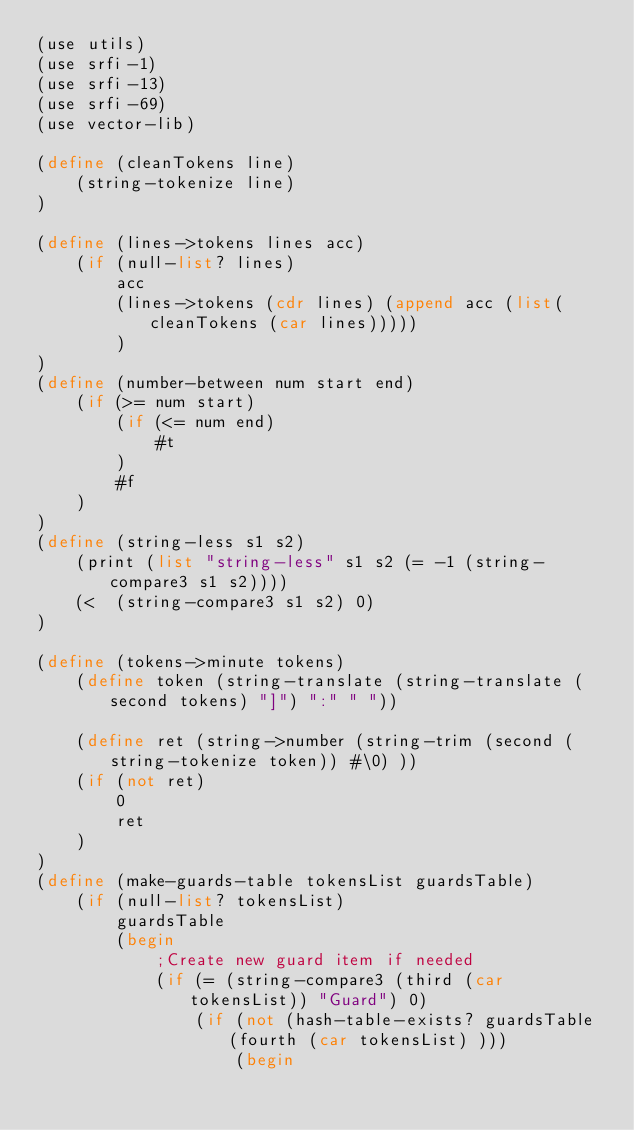<code> <loc_0><loc_0><loc_500><loc_500><_Scheme_>(use utils)
(use srfi-1)
(use srfi-13)
(use srfi-69)
(use vector-lib)

(define (cleanTokens line)
	(string-tokenize line)
)

(define (lines->tokens lines acc)
	(if (null-list? lines)
		acc
		(lines->tokens (cdr lines) (append acc (list(cleanTokens (car lines)))))
		)
)
(define (number-between num start end)
	(if (>= num start)
		(if (<= num end)
			#t
		)
		#f
	)
)
(define (string-less s1 s2)
    (print (list "string-less" s1 s2 (= -1 (string-compare3 s1 s2))))
	(<  (string-compare3 s1 s2) 0)
)

(define (tokens->minute tokens)
	(define token (string-translate (string-translate (second tokens) "]") ":" " "))
	
	(define ret (string->number (string-trim (second (string-tokenize token)) #\0) ))
	(if (not ret)
		0
		ret
	)
)
(define (make-guards-table tokensList guardsTable)
	(if (null-list? tokensList)
		guardsTable
		(begin 
			;Create new guard item if needed
			(if (= (string-compare3 (third (car tokensList)) "Guard") 0)
				(if (not (hash-table-exists? guardsTable (fourth (car tokensList) )))
					(begin</code> 